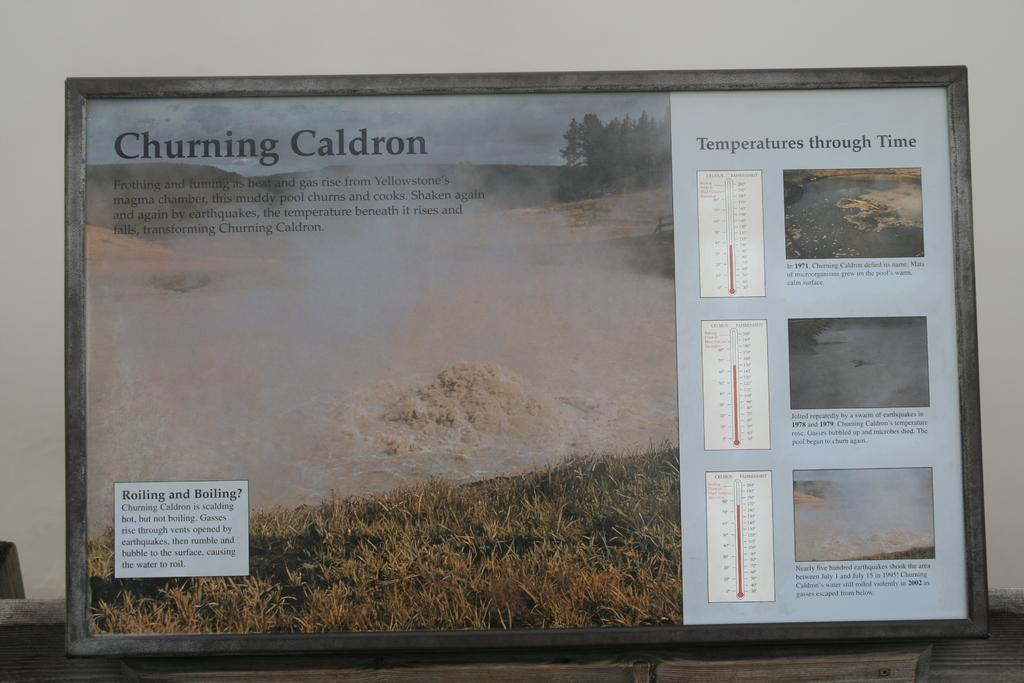What is the main subject of the image? The main subject of the image is a frame on a platform. What elements can be found inside the frame? Inside the frame, there is grass, water, trees, thermometers, and the sky is visible. Is there any text present in the image? Yes, there is text in the frame. What can be seen in the background of the image? There is a wall in the background of the image. How many boys are washing soda in the image? There are no boys or soda present in the image. 